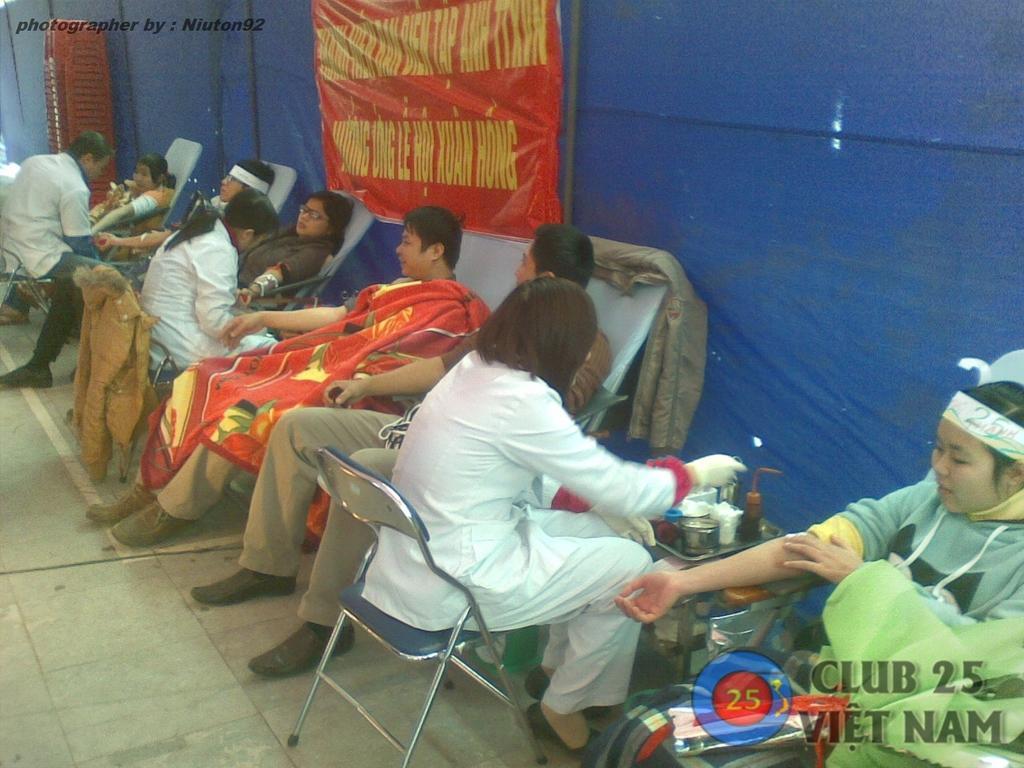How would you summarize this image in a sentence or two? In the image we can see there are many people sitting, wearing clothes and shoes. Here we can see the bottle, cotton and many other things kept on the tray. Here we can see the poster and text on it. We can even see the curtains and chairs. On the bottom right and left top we can see water mark. 